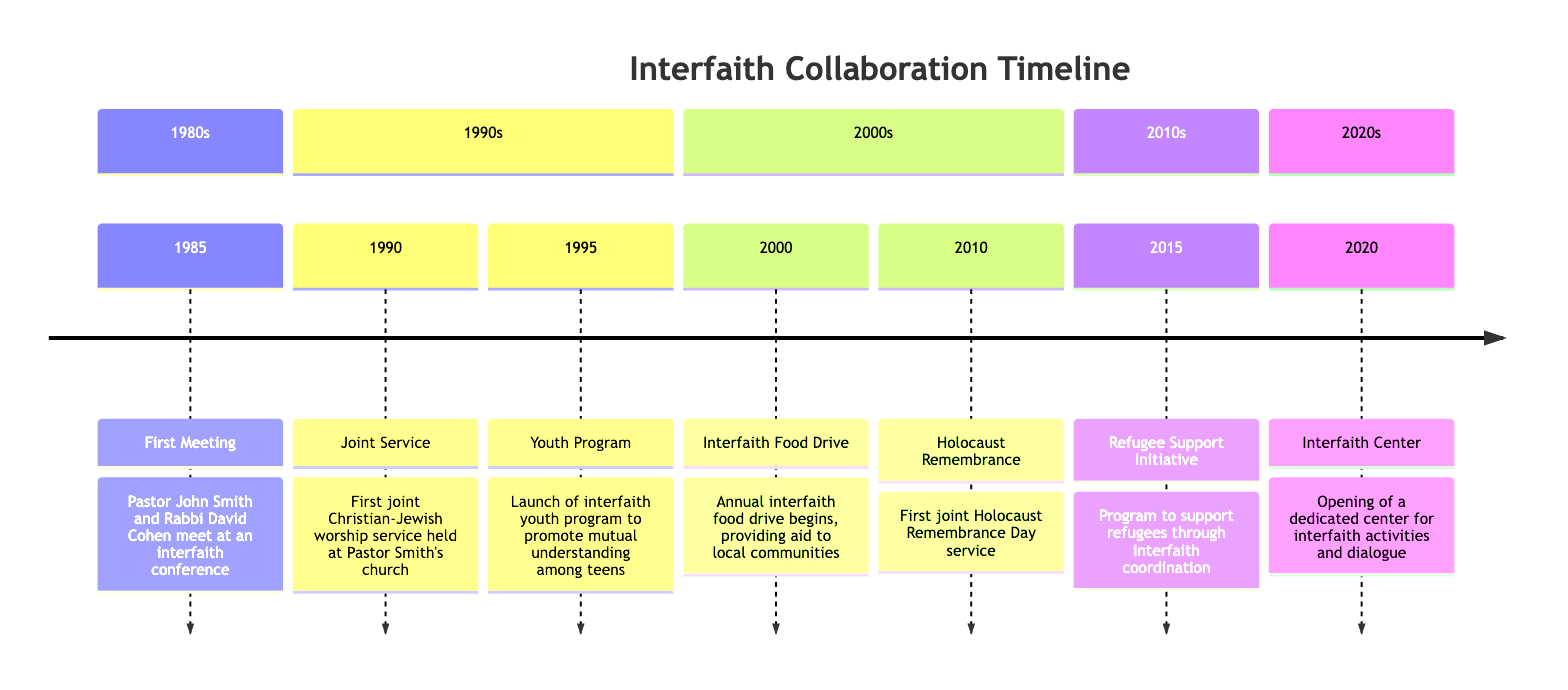What year did Pastor John Smith and Rabbi David Cohen first meet? The timeline indicates that Pastor John Smith and Rabbi David Cohen met in 1985 at an interfaith conference, which is the earliest listed event on the timeline.
Answer: 1985 How many joint initiatives are listed for the 1990s? By reviewing the timeline, I see that there are two initiatives listed for the 1990s: the first joint service in 1990 and the youth program in 1995.
Answer: 2 What is the significant milestone that occurred in 2000? The timeline clearly marks that in 2000, the Interfaith Food Drive began, which is highlighted as a significant community initiative within that decade.
Answer: Interfaith Food Drive Which event is the last one mentioned on the timeline? The timeline ends with the opening of the Interfaith Center in 2020, indicating that this is the most recent milestone in their collaboration.
Answer: Interfaith Center What type of initiative was launched in 2015? Analyzing the timeline, the Refugee Support Initiative was launched in 2015, which is categorized as a program aimed at supporting refugees through interfaith efforts.
Answer: Refugee Support Initiative Which decade saw the first Holocaust Remembrance Day service? The timeline shows that the first joint Holocaust Remembrance Day service occurred in 2010, placing it in the 2000s.
Answer: 2010 How many total events are listed in the 2010s? There is only one event listed in the 2010s, which is the Refugee Support Initiative in 2015, making this a straightforward count.
Answer: 1 In what year was the joint Christian-Jewish worship service held? The timeline specifically states that the first joint Christian-Jewish worship service took place in 1990, highlighting this milestone.
Answer: 1990 